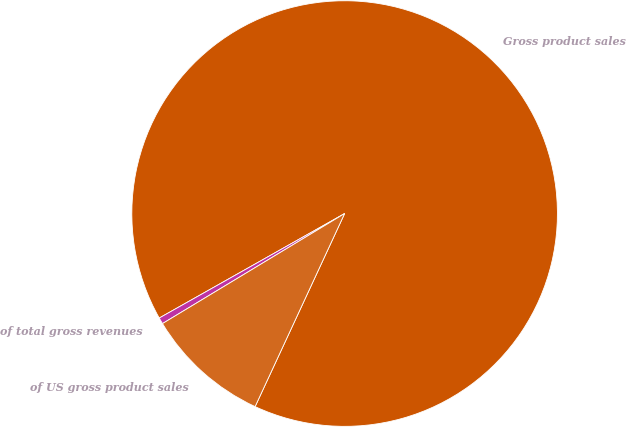Convert chart to OTSL. <chart><loc_0><loc_0><loc_500><loc_500><pie_chart><fcel>Gross product sales<fcel>of total gross revenues<fcel>of US gross product sales<nl><fcel>90.07%<fcel>0.48%<fcel>9.44%<nl></chart> 